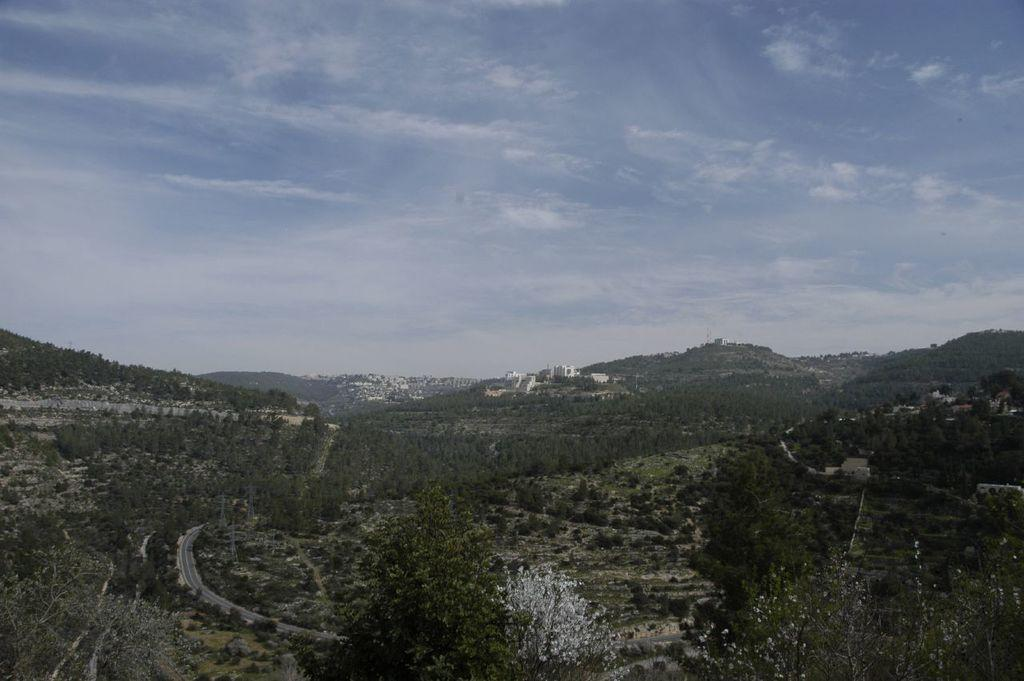What type of natural vegetation can be seen in the image? There are trees in the image. What is visible beneath the trees and buildings? The ground is visible in the image. What type of man-made structure is present in the image? There is a road and buildings in the image. What can be seen in the distance behind the trees and buildings? There are mountains and the sky visible in the background of the image. What is the grade of the eggnog being served in the image? There is no eggnog present in the image. How many thumbs can be seen in the image? There are no thumbs visible in the image. 